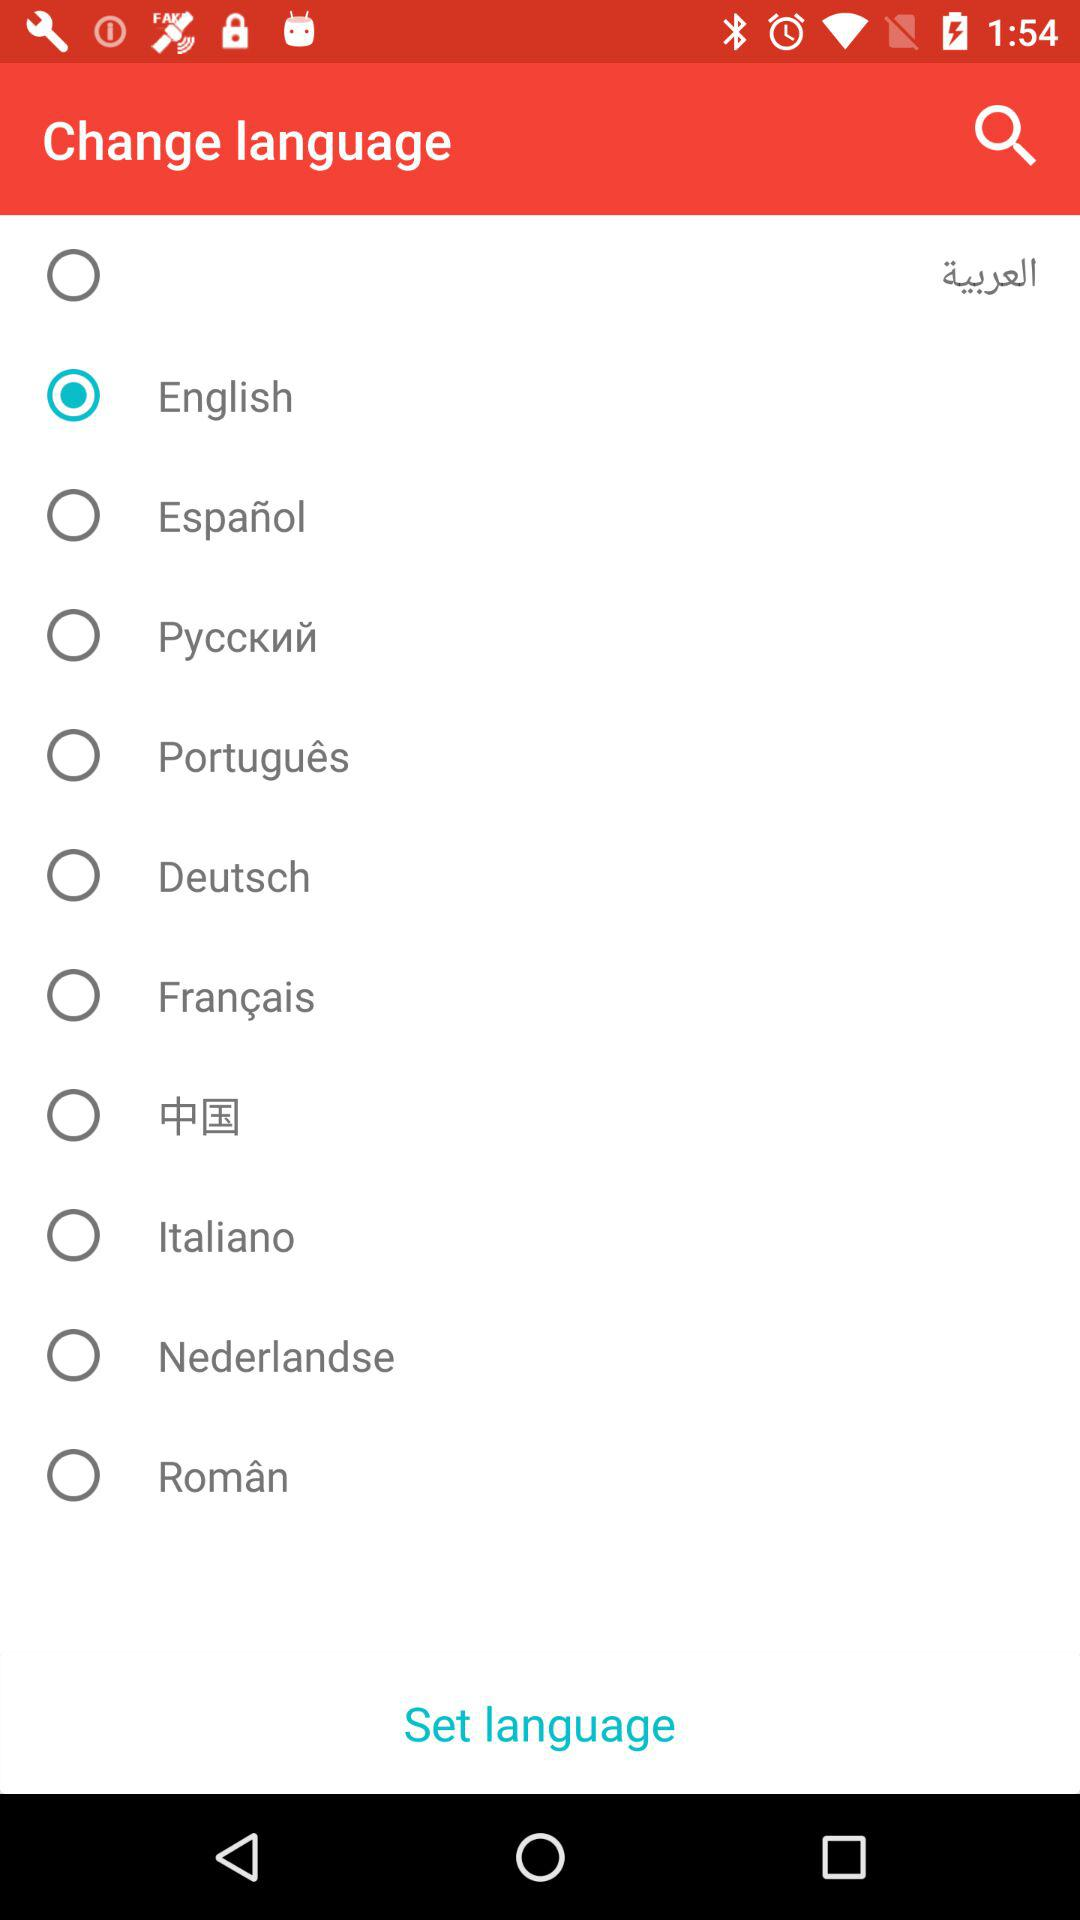How many languages are available for selection?
Answer the question using a single word or phrase. 10 